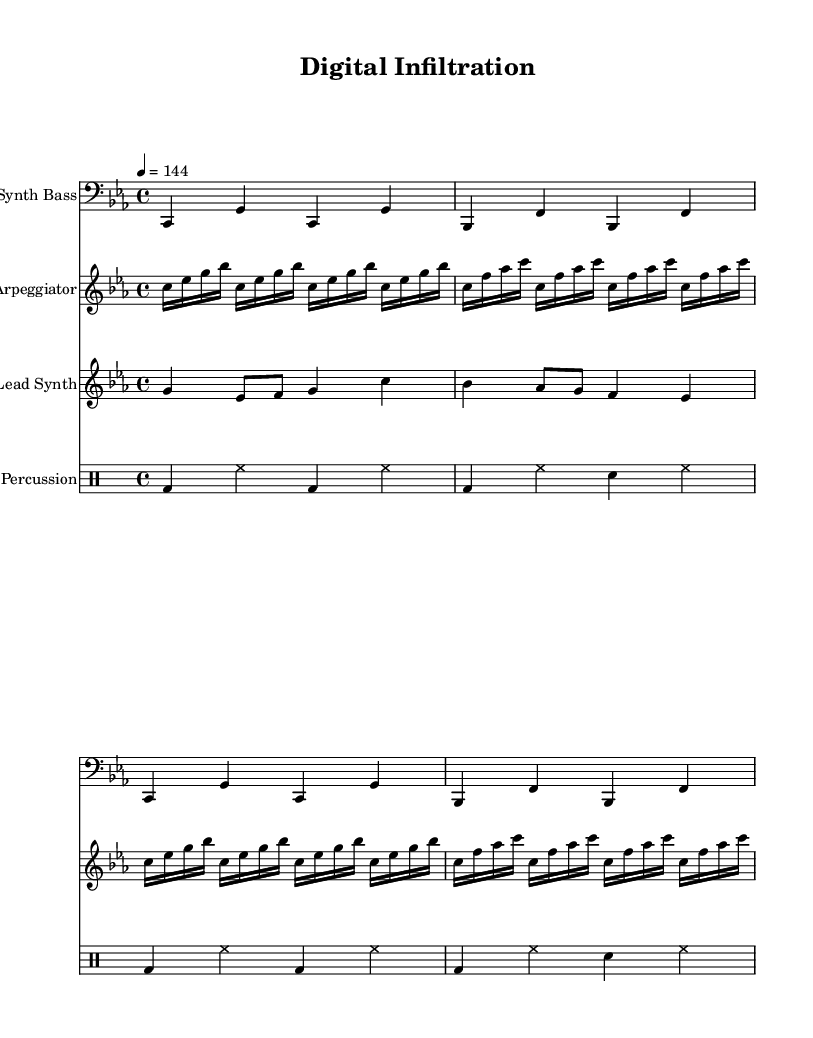What is the key signature of this music? The key signature is C minor, which has three flat notes: B flat, E flat, and A flat. This can be confirmed by looking at the key signature indicator at the beginning of the sheet music.
Answer: C minor What is the time signature of this music? The time signature is 4/4, indicating that there are four beats in each measure and the quarter note gets one beat. This can be verified by examining the time signature indicator found at the start of the score.
Answer: 4/4 What is the tempo marking in this piece? The tempo marking is 144 beats per minute, as specified in the tempo directive at the start of the music. This indicates the piece is fast-paced, suitable for techno music.
Answer: 144 How many measures are in the Synth Bass section? The Synth Bass section consists of 4 measures, as it is repeated twice in the notation. Each repeat of the section holds 2 measures, totaling 4 when combined.
Answer: 4 What instrument is playing the lead synth part? The lead synth part is played by a "Lead Synth," as indicated by the instrument name at the beginning of that staff. This label designates which sounds or musical elements are represented in that section.
Answer: Lead Synth What rhythmic pattern does the percussion section follow? The percussion section follows a simple alternating pattern between bass drums (bd), hi-hats (hh), and snare drums (sn). The pattern can be observed by noting the consistent arrangement of these elements in the notation.
Answer: Alternating pattern How many notes are in the first arpeggio repetition? The first arpeggio repetition features 16 notes, as there are 4 sets of 4 sixteenth notes in the notated passage. This can be determined by counting the sixteenth notes in that section.
Answer: 16 